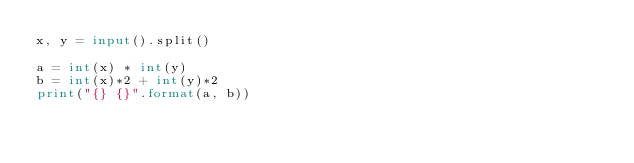Convert code to text. <code><loc_0><loc_0><loc_500><loc_500><_Python_>x, y = input().split()

a = int(x) * int(y)
b = int(x)*2 + int(y)*2
print("{} {}".format(a, b))</code> 